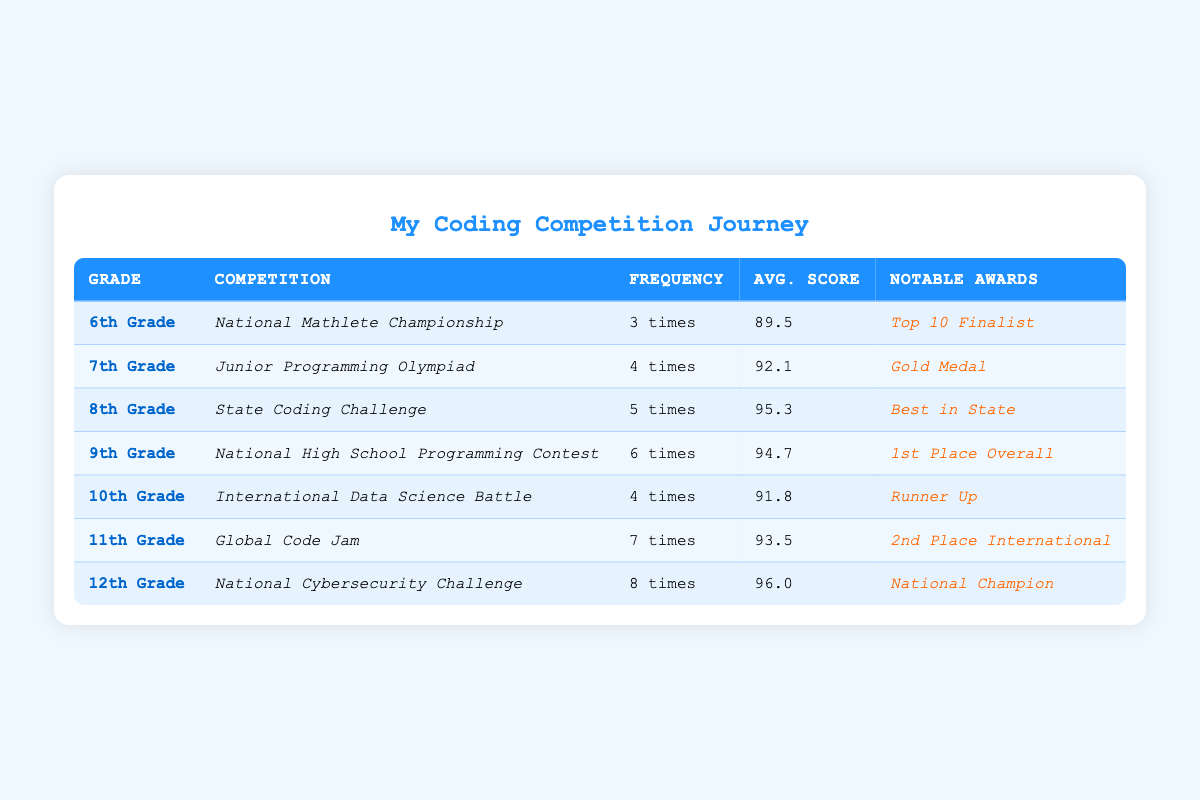What is the participation frequency for 12th Grade? The table shows that for 12th Grade, the participation frequency in the coding competition is listed as "8 times."
Answer: 8 times Which grade level has the highest average score? To find the highest average score, we compare the average scores across all grade levels. The scores are: 89.5, 92.1, 95.3, 94.7, 91.8, 93.5, and 96.0. The highest score is 96.0, which corresponds to 12th Grade.
Answer: 12th Grade Did any students from 11th Grade win a notable award? Referring to the table, 11th Grade has a notable award listed as "2nd Place International." Since there is an award mentioned, the answer is yes.
Answer: Yes What is the total number of competition participations across all grades? We sum the participation frequencies: 3 + 4 + 5 + 6 + 4 + 7 + 8 = 37 total participations.
Answer: 37 Which competition was participated in the most across all grades? The competitions are compared for their participation frequency. The competition with the highest participation, according to the table, is the "National Cybersecurity Challenge" for 12th Grade with 8 participations. There are no other competitions with higher frequency.
Answer: National Cybersecurity Challenge Calculate the average score of participants in 10th and 11th Grade combined. The average scores for 10th and 11th Grade are 91.8 and 93.5, respectively. To get the combined average, we calculate: (91.8 + 93.5) / 2 = 92.65.
Answer: 92.65 Is there a grade level that participated in more than 5 competitions? The table indicates that 9th Grade (6 times), 11th Grade (7 times), and 12th Grade (8 times) participated in more than 5 competitions.
Answer: Yes What is the notable award for the competition in the 9th Grade? According to the table, the notable award listed for the 9th Grade is "1st Place Overall."
Answer: 1st Place Overall Which grade level has the smallest average score? By reviewing the average scores for each grade, the smallest average score of 89.5 belongs to the 6th Grade.
Answer: 6th Grade How many competitions did 8th Grade participate in compared to 7th Grade? The participation frequency for 8th Grade is 5 times, while for 7th Grade, it is 4 times. Therefore, 8th Grade participated in 1 more competition than 7th Grade.
Answer: 1 more competition 